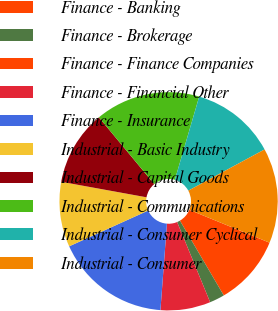Convert chart. <chart><loc_0><loc_0><loc_500><loc_500><pie_chart><fcel>Finance - Banking<fcel>Finance - Brokerage<fcel>Finance - Finance Companies<fcel>Finance - Financial Other<fcel>Finance - Insurance<fcel>Industrial - Basic Industry<fcel>Industrial - Capital Goods<fcel>Industrial - Communications<fcel>Industrial - Consumer Cyclical<fcel>Industrial - Consumer<nl><fcel>10.37%<fcel>2.22%<fcel>0.0%<fcel>7.41%<fcel>17.04%<fcel>9.63%<fcel>11.11%<fcel>15.55%<fcel>12.59%<fcel>14.07%<nl></chart> 